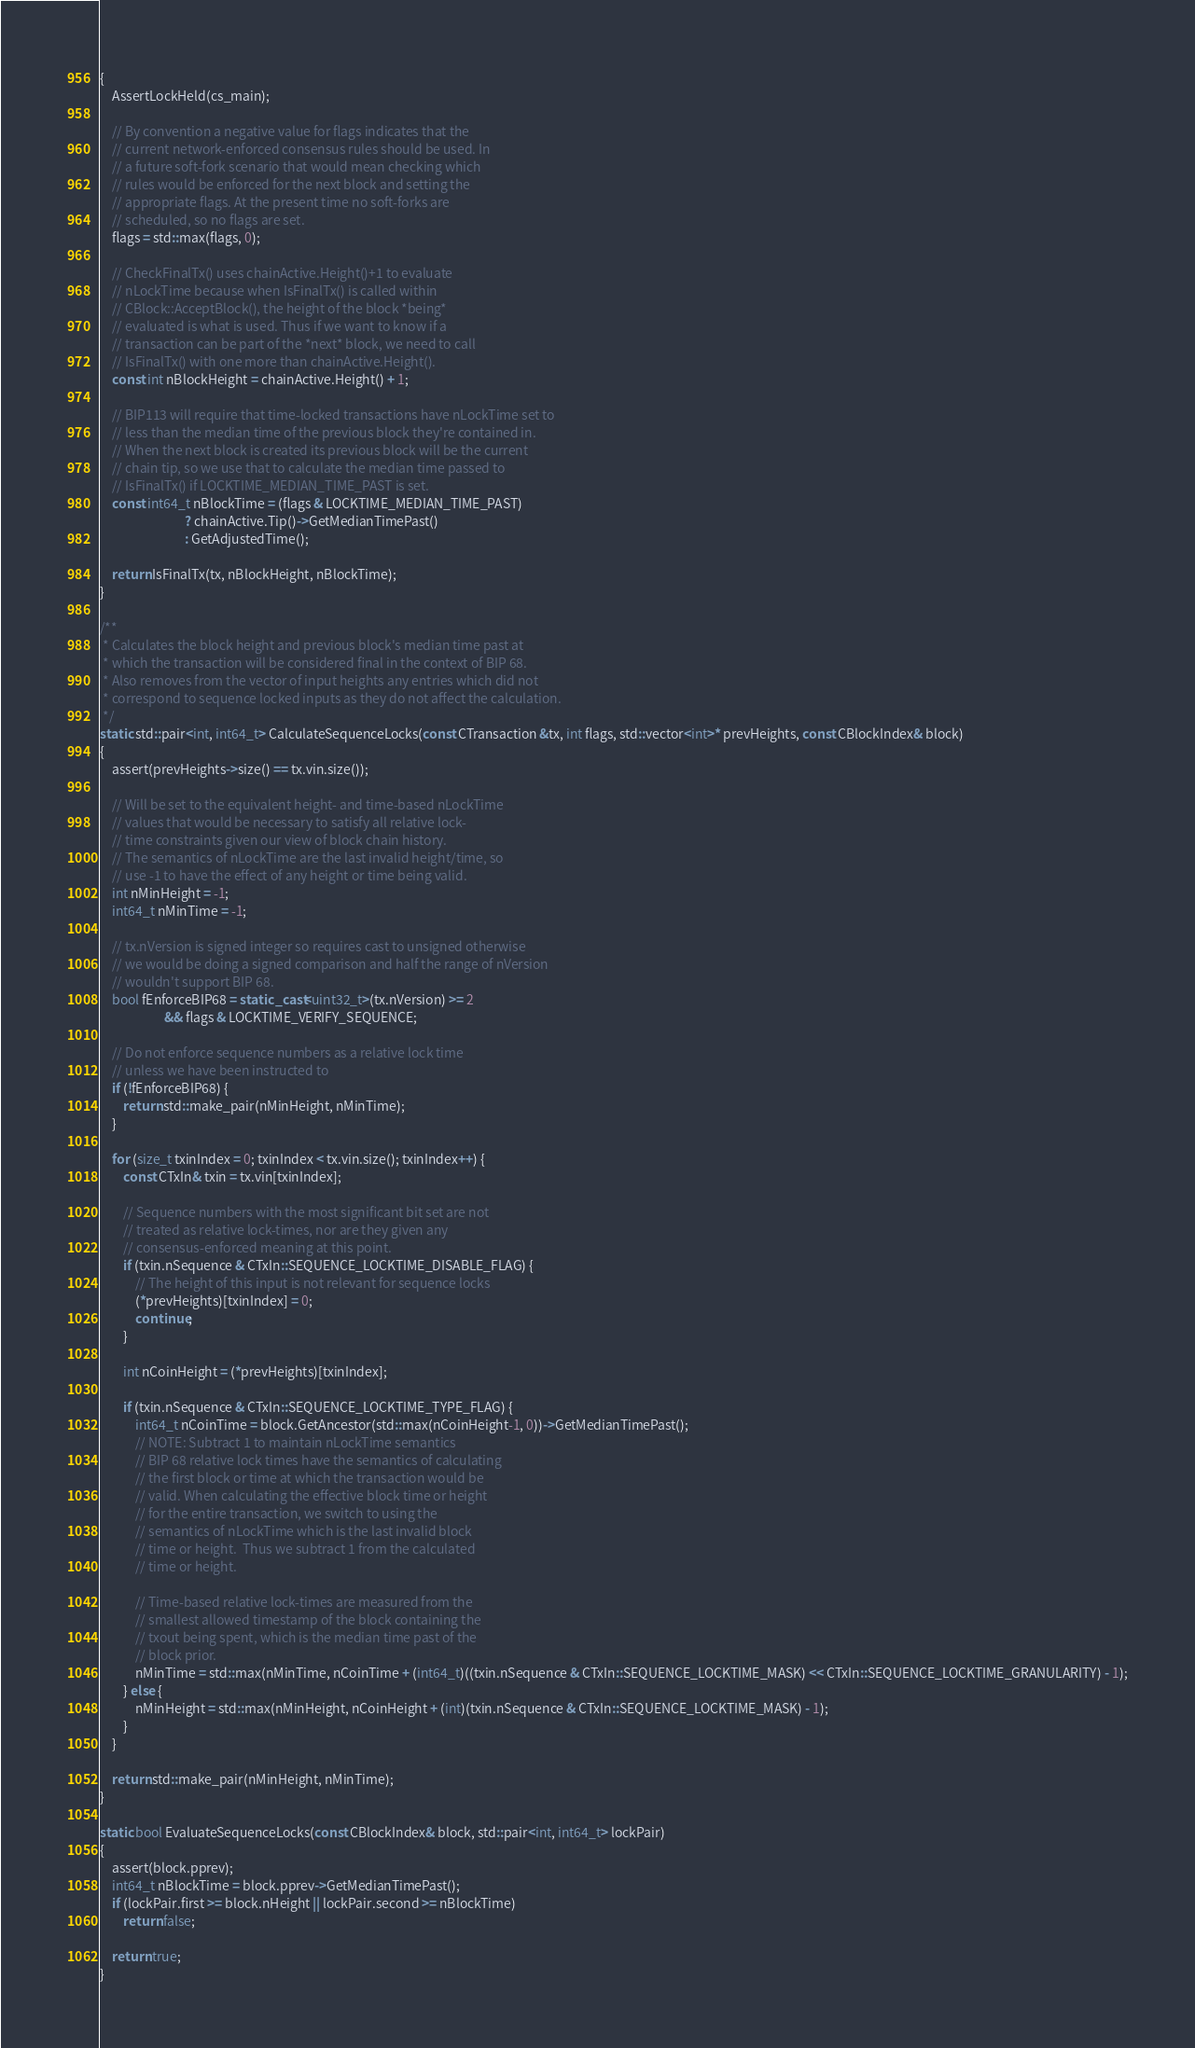Convert code to text. <code><loc_0><loc_0><loc_500><loc_500><_C++_>{
    AssertLockHeld(cs_main);

    // By convention a negative value for flags indicates that the
    // current network-enforced consensus rules should be used. In
    // a future soft-fork scenario that would mean checking which
    // rules would be enforced for the next block and setting the
    // appropriate flags. At the present time no soft-forks are
    // scheduled, so no flags are set.
    flags = std::max(flags, 0);

    // CheckFinalTx() uses chainActive.Height()+1 to evaluate
    // nLockTime because when IsFinalTx() is called within
    // CBlock::AcceptBlock(), the height of the block *being*
    // evaluated is what is used. Thus if we want to know if a
    // transaction can be part of the *next* block, we need to call
    // IsFinalTx() with one more than chainActive.Height().
    const int nBlockHeight = chainActive.Height() + 1;

    // BIP113 will require that time-locked transactions have nLockTime set to
    // less than the median time of the previous block they're contained in.
    // When the next block is created its previous block will be the current
    // chain tip, so we use that to calculate the median time passed to
    // IsFinalTx() if LOCKTIME_MEDIAN_TIME_PAST is set.
    const int64_t nBlockTime = (flags & LOCKTIME_MEDIAN_TIME_PAST)
                             ? chainActive.Tip()->GetMedianTimePast()
                             : GetAdjustedTime();

    return IsFinalTx(tx, nBlockHeight, nBlockTime);
}

/**
 * Calculates the block height and previous block's median time past at
 * which the transaction will be considered final in the context of BIP 68.
 * Also removes from the vector of input heights any entries which did not
 * correspond to sequence locked inputs as they do not affect the calculation.
 */
static std::pair<int, int64_t> CalculateSequenceLocks(const CTransaction &tx, int flags, std::vector<int>* prevHeights, const CBlockIndex& block)
{
    assert(prevHeights->size() == tx.vin.size());

    // Will be set to the equivalent height- and time-based nLockTime
    // values that would be necessary to satisfy all relative lock-
    // time constraints given our view of block chain history.
    // The semantics of nLockTime are the last invalid height/time, so
    // use -1 to have the effect of any height or time being valid.
    int nMinHeight = -1;
    int64_t nMinTime = -1;

    // tx.nVersion is signed integer so requires cast to unsigned otherwise
    // we would be doing a signed comparison and half the range of nVersion
    // wouldn't support BIP 68.
    bool fEnforceBIP68 = static_cast<uint32_t>(tx.nVersion) >= 2
                      && flags & LOCKTIME_VERIFY_SEQUENCE;

    // Do not enforce sequence numbers as a relative lock time
    // unless we have been instructed to
    if (!fEnforceBIP68) {
        return std::make_pair(nMinHeight, nMinTime);
    }

    for (size_t txinIndex = 0; txinIndex < tx.vin.size(); txinIndex++) {
        const CTxIn& txin = tx.vin[txinIndex];

        // Sequence numbers with the most significant bit set are not
        // treated as relative lock-times, nor are they given any
        // consensus-enforced meaning at this point.
        if (txin.nSequence & CTxIn::SEQUENCE_LOCKTIME_DISABLE_FLAG) {
            // The height of this input is not relevant for sequence locks
            (*prevHeights)[txinIndex] = 0;
            continue;
        }

        int nCoinHeight = (*prevHeights)[txinIndex];

        if (txin.nSequence & CTxIn::SEQUENCE_LOCKTIME_TYPE_FLAG) {
            int64_t nCoinTime = block.GetAncestor(std::max(nCoinHeight-1, 0))->GetMedianTimePast();
            // NOTE: Subtract 1 to maintain nLockTime semantics
            // BIP 68 relative lock times have the semantics of calculating
            // the first block or time at which the transaction would be
            // valid. When calculating the effective block time or height
            // for the entire transaction, we switch to using the
            // semantics of nLockTime which is the last invalid block
            // time or height.  Thus we subtract 1 from the calculated
            // time or height.

            // Time-based relative lock-times are measured from the
            // smallest allowed timestamp of the block containing the
            // txout being spent, which is the median time past of the
            // block prior.
            nMinTime = std::max(nMinTime, nCoinTime + (int64_t)((txin.nSequence & CTxIn::SEQUENCE_LOCKTIME_MASK) << CTxIn::SEQUENCE_LOCKTIME_GRANULARITY) - 1);
        } else {
            nMinHeight = std::max(nMinHeight, nCoinHeight + (int)(txin.nSequence & CTxIn::SEQUENCE_LOCKTIME_MASK) - 1);
        }
    }

    return std::make_pair(nMinHeight, nMinTime);
}

static bool EvaluateSequenceLocks(const CBlockIndex& block, std::pair<int, int64_t> lockPair)
{
    assert(block.pprev);
    int64_t nBlockTime = block.pprev->GetMedianTimePast();
    if (lockPair.first >= block.nHeight || lockPair.second >= nBlockTime)
        return false;

    return true;
}
</code> 